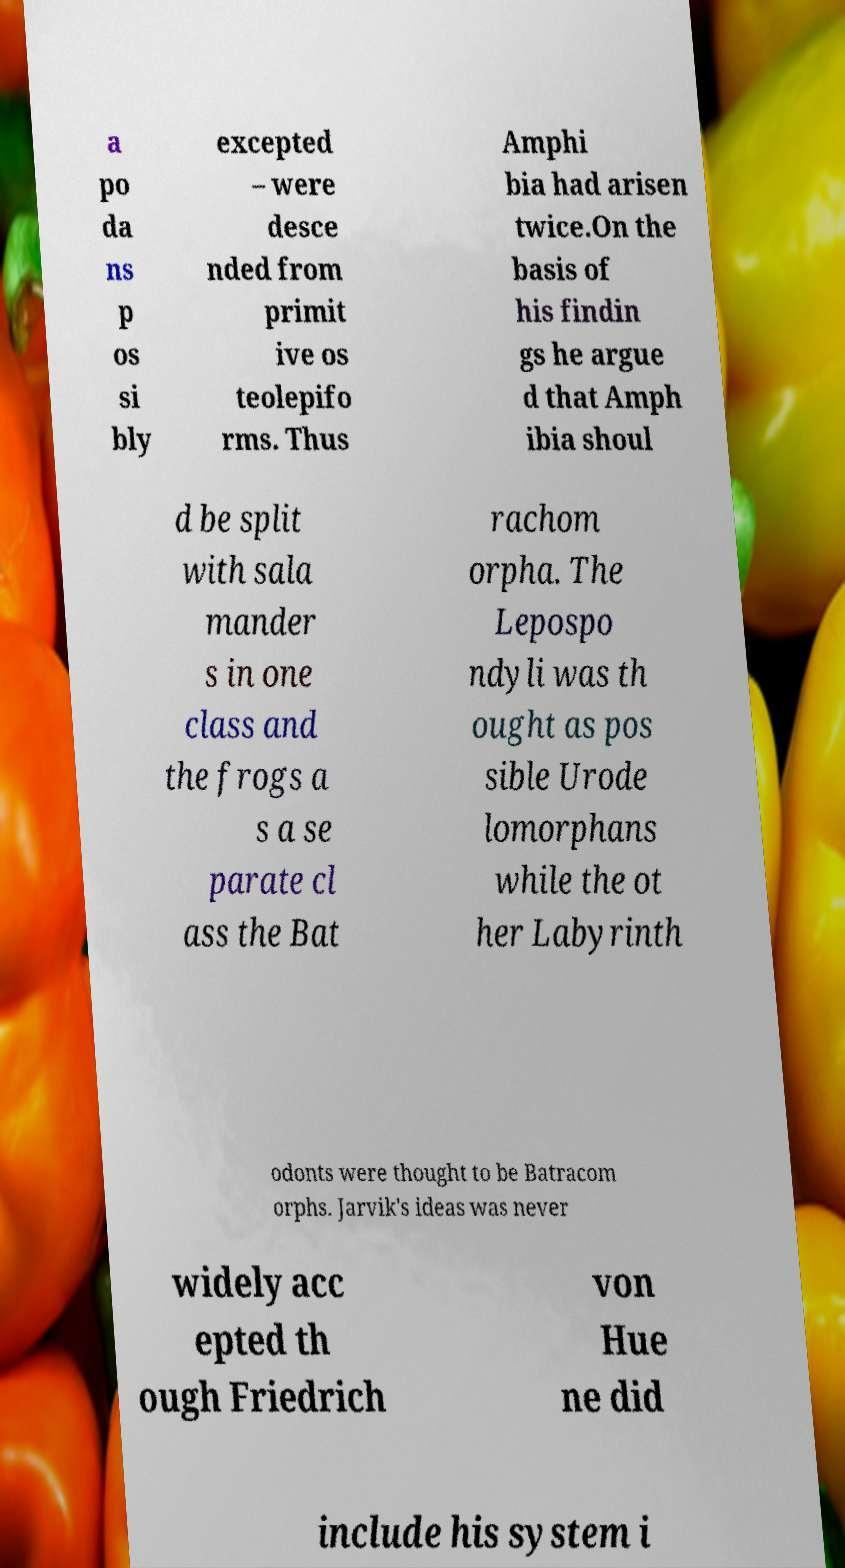I need the written content from this picture converted into text. Can you do that? a po da ns p os si bly excepted – were desce nded from primit ive os teolepifo rms. Thus Amphi bia had arisen twice.On the basis of his findin gs he argue d that Amph ibia shoul d be split with sala mander s in one class and the frogs a s a se parate cl ass the Bat rachom orpha. The Lepospo ndyli was th ought as pos sible Urode lomorphans while the ot her Labyrinth odonts were thought to be Batracom orphs. Jarvik's ideas was never widely acc epted th ough Friedrich von Hue ne did include his system i 